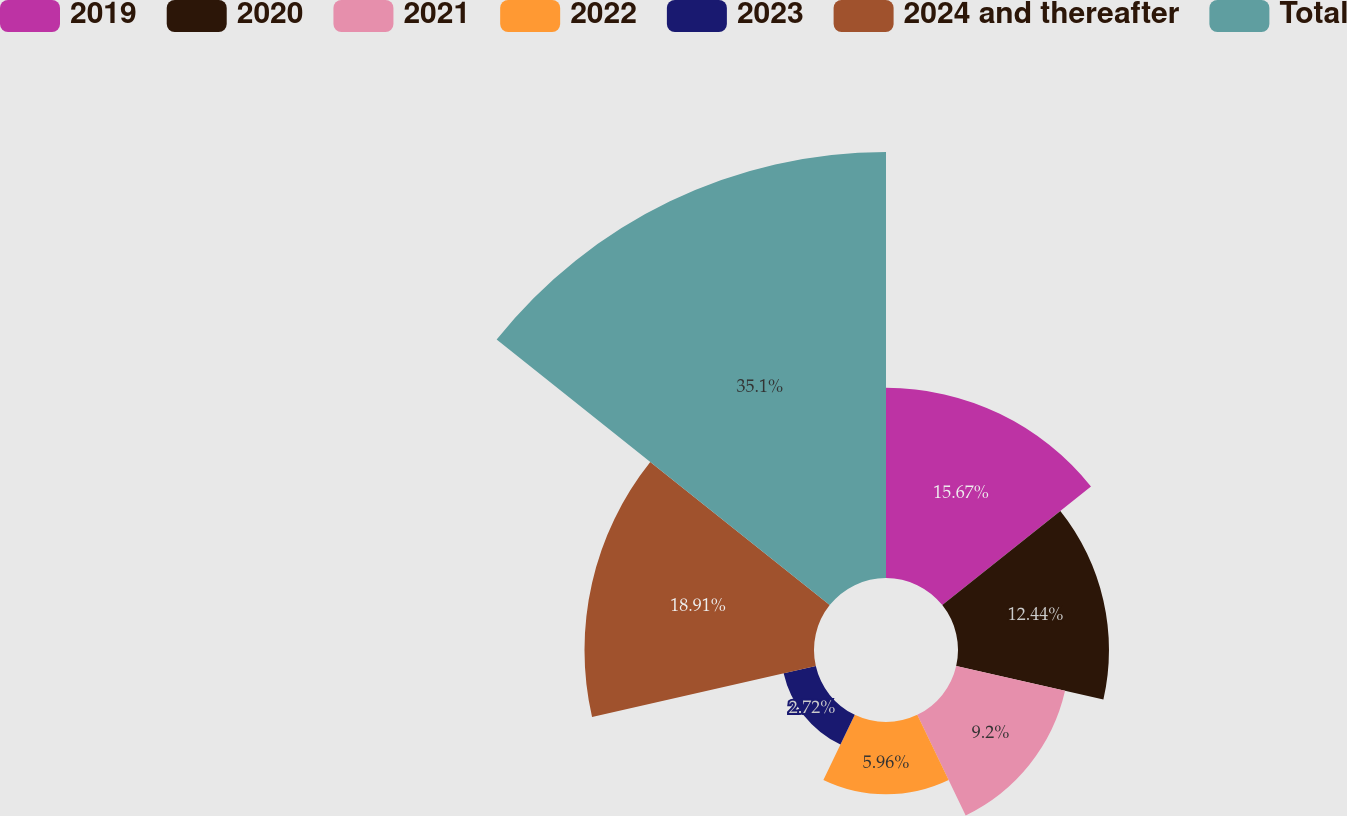<chart> <loc_0><loc_0><loc_500><loc_500><pie_chart><fcel>2019<fcel>2020<fcel>2021<fcel>2022<fcel>2023<fcel>2024 and thereafter<fcel>Total<nl><fcel>15.67%<fcel>12.44%<fcel>9.2%<fcel>5.96%<fcel>2.72%<fcel>18.91%<fcel>35.1%<nl></chart> 